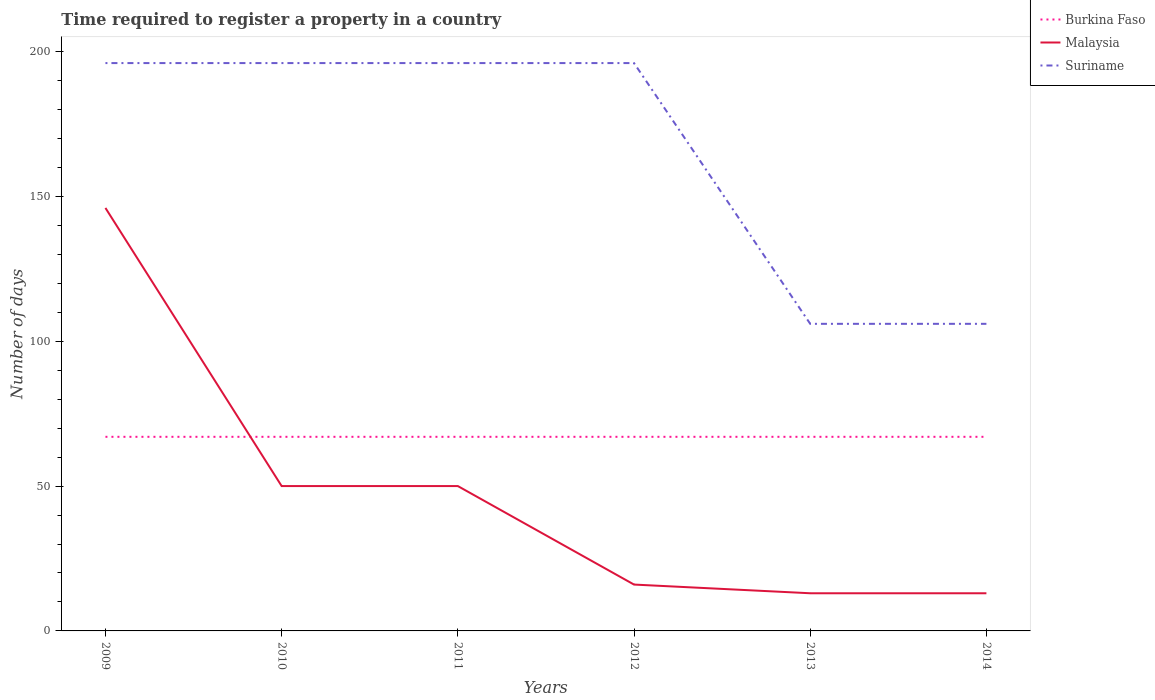How many different coloured lines are there?
Provide a succinct answer. 3. Does the line corresponding to Malaysia intersect with the line corresponding to Burkina Faso?
Your answer should be very brief. Yes. Across all years, what is the maximum number of days required to register a property in Malaysia?
Your answer should be very brief. 13. What is the total number of days required to register a property in Malaysia in the graph?
Offer a very short reply. 96. Is the number of days required to register a property in Malaysia strictly greater than the number of days required to register a property in Burkina Faso over the years?
Provide a short and direct response. No. How many years are there in the graph?
Offer a very short reply. 6. Does the graph contain any zero values?
Make the answer very short. No. Where does the legend appear in the graph?
Make the answer very short. Top right. How many legend labels are there?
Make the answer very short. 3. What is the title of the graph?
Your response must be concise. Time required to register a property in a country. What is the label or title of the Y-axis?
Give a very brief answer. Number of days. What is the Number of days of Burkina Faso in 2009?
Provide a short and direct response. 67. What is the Number of days in Malaysia in 2009?
Make the answer very short. 146. What is the Number of days in Suriname in 2009?
Offer a terse response. 196. What is the Number of days of Malaysia in 2010?
Keep it short and to the point. 50. What is the Number of days in Suriname in 2010?
Your answer should be compact. 196. What is the Number of days in Burkina Faso in 2011?
Your response must be concise. 67. What is the Number of days of Malaysia in 2011?
Keep it short and to the point. 50. What is the Number of days of Suriname in 2011?
Your response must be concise. 196. What is the Number of days of Burkina Faso in 2012?
Offer a terse response. 67. What is the Number of days in Suriname in 2012?
Offer a very short reply. 196. What is the Number of days of Malaysia in 2013?
Ensure brevity in your answer.  13. What is the Number of days in Suriname in 2013?
Provide a succinct answer. 106. What is the Number of days of Malaysia in 2014?
Offer a terse response. 13. What is the Number of days of Suriname in 2014?
Offer a terse response. 106. Across all years, what is the maximum Number of days of Burkina Faso?
Provide a succinct answer. 67. Across all years, what is the maximum Number of days in Malaysia?
Ensure brevity in your answer.  146. Across all years, what is the maximum Number of days in Suriname?
Provide a short and direct response. 196. Across all years, what is the minimum Number of days of Burkina Faso?
Make the answer very short. 67. Across all years, what is the minimum Number of days of Malaysia?
Your response must be concise. 13. Across all years, what is the minimum Number of days of Suriname?
Keep it short and to the point. 106. What is the total Number of days in Burkina Faso in the graph?
Your response must be concise. 402. What is the total Number of days of Malaysia in the graph?
Keep it short and to the point. 288. What is the total Number of days of Suriname in the graph?
Offer a terse response. 996. What is the difference between the Number of days in Malaysia in 2009 and that in 2010?
Your answer should be compact. 96. What is the difference between the Number of days of Burkina Faso in 2009 and that in 2011?
Your answer should be compact. 0. What is the difference between the Number of days in Malaysia in 2009 and that in 2011?
Your answer should be very brief. 96. What is the difference between the Number of days of Burkina Faso in 2009 and that in 2012?
Offer a very short reply. 0. What is the difference between the Number of days in Malaysia in 2009 and that in 2012?
Offer a terse response. 130. What is the difference between the Number of days in Suriname in 2009 and that in 2012?
Your answer should be very brief. 0. What is the difference between the Number of days in Malaysia in 2009 and that in 2013?
Ensure brevity in your answer.  133. What is the difference between the Number of days in Suriname in 2009 and that in 2013?
Offer a very short reply. 90. What is the difference between the Number of days in Malaysia in 2009 and that in 2014?
Give a very brief answer. 133. What is the difference between the Number of days of Malaysia in 2010 and that in 2011?
Your answer should be compact. 0. What is the difference between the Number of days of Suriname in 2010 and that in 2011?
Make the answer very short. 0. What is the difference between the Number of days in Malaysia in 2010 and that in 2012?
Your response must be concise. 34. What is the difference between the Number of days of Suriname in 2010 and that in 2013?
Make the answer very short. 90. What is the difference between the Number of days in Burkina Faso in 2010 and that in 2014?
Offer a terse response. 0. What is the difference between the Number of days in Malaysia in 2010 and that in 2014?
Provide a succinct answer. 37. What is the difference between the Number of days of Malaysia in 2011 and that in 2012?
Give a very brief answer. 34. What is the difference between the Number of days of Burkina Faso in 2011 and that in 2013?
Your answer should be compact. 0. What is the difference between the Number of days of Burkina Faso in 2011 and that in 2014?
Ensure brevity in your answer.  0. What is the difference between the Number of days of Burkina Faso in 2012 and that in 2014?
Provide a short and direct response. 0. What is the difference between the Number of days in Suriname in 2013 and that in 2014?
Your response must be concise. 0. What is the difference between the Number of days of Burkina Faso in 2009 and the Number of days of Suriname in 2010?
Provide a short and direct response. -129. What is the difference between the Number of days of Burkina Faso in 2009 and the Number of days of Suriname in 2011?
Provide a succinct answer. -129. What is the difference between the Number of days in Burkina Faso in 2009 and the Number of days in Suriname in 2012?
Offer a terse response. -129. What is the difference between the Number of days of Burkina Faso in 2009 and the Number of days of Malaysia in 2013?
Ensure brevity in your answer.  54. What is the difference between the Number of days in Burkina Faso in 2009 and the Number of days in Suriname in 2013?
Ensure brevity in your answer.  -39. What is the difference between the Number of days in Burkina Faso in 2009 and the Number of days in Suriname in 2014?
Your answer should be very brief. -39. What is the difference between the Number of days of Malaysia in 2009 and the Number of days of Suriname in 2014?
Ensure brevity in your answer.  40. What is the difference between the Number of days of Burkina Faso in 2010 and the Number of days of Suriname in 2011?
Provide a succinct answer. -129. What is the difference between the Number of days of Malaysia in 2010 and the Number of days of Suriname in 2011?
Your answer should be very brief. -146. What is the difference between the Number of days of Burkina Faso in 2010 and the Number of days of Suriname in 2012?
Give a very brief answer. -129. What is the difference between the Number of days of Malaysia in 2010 and the Number of days of Suriname in 2012?
Provide a succinct answer. -146. What is the difference between the Number of days of Burkina Faso in 2010 and the Number of days of Malaysia in 2013?
Your answer should be very brief. 54. What is the difference between the Number of days in Burkina Faso in 2010 and the Number of days in Suriname in 2013?
Make the answer very short. -39. What is the difference between the Number of days of Malaysia in 2010 and the Number of days of Suriname in 2013?
Offer a terse response. -56. What is the difference between the Number of days of Burkina Faso in 2010 and the Number of days of Suriname in 2014?
Offer a very short reply. -39. What is the difference between the Number of days of Malaysia in 2010 and the Number of days of Suriname in 2014?
Provide a short and direct response. -56. What is the difference between the Number of days of Burkina Faso in 2011 and the Number of days of Suriname in 2012?
Ensure brevity in your answer.  -129. What is the difference between the Number of days in Malaysia in 2011 and the Number of days in Suriname in 2012?
Your answer should be compact. -146. What is the difference between the Number of days of Burkina Faso in 2011 and the Number of days of Malaysia in 2013?
Provide a succinct answer. 54. What is the difference between the Number of days of Burkina Faso in 2011 and the Number of days of Suriname in 2013?
Offer a very short reply. -39. What is the difference between the Number of days in Malaysia in 2011 and the Number of days in Suriname in 2013?
Ensure brevity in your answer.  -56. What is the difference between the Number of days in Burkina Faso in 2011 and the Number of days in Malaysia in 2014?
Keep it short and to the point. 54. What is the difference between the Number of days in Burkina Faso in 2011 and the Number of days in Suriname in 2014?
Your response must be concise. -39. What is the difference between the Number of days in Malaysia in 2011 and the Number of days in Suriname in 2014?
Offer a very short reply. -56. What is the difference between the Number of days of Burkina Faso in 2012 and the Number of days of Malaysia in 2013?
Your response must be concise. 54. What is the difference between the Number of days in Burkina Faso in 2012 and the Number of days in Suriname in 2013?
Your response must be concise. -39. What is the difference between the Number of days in Malaysia in 2012 and the Number of days in Suriname in 2013?
Your answer should be compact. -90. What is the difference between the Number of days of Burkina Faso in 2012 and the Number of days of Suriname in 2014?
Your response must be concise. -39. What is the difference between the Number of days in Malaysia in 2012 and the Number of days in Suriname in 2014?
Keep it short and to the point. -90. What is the difference between the Number of days in Burkina Faso in 2013 and the Number of days in Suriname in 2014?
Offer a terse response. -39. What is the difference between the Number of days of Malaysia in 2013 and the Number of days of Suriname in 2014?
Offer a very short reply. -93. What is the average Number of days of Suriname per year?
Provide a succinct answer. 166. In the year 2009, what is the difference between the Number of days of Burkina Faso and Number of days of Malaysia?
Your answer should be very brief. -79. In the year 2009, what is the difference between the Number of days in Burkina Faso and Number of days in Suriname?
Your answer should be very brief. -129. In the year 2009, what is the difference between the Number of days of Malaysia and Number of days of Suriname?
Make the answer very short. -50. In the year 2010, what is the difference between the Number of days in Burkina Faso and Number of days in Suriname?
Provide a short and direct response. -129. In the year 2010, what is the difference between the Number of days of Malaysia and Number of days of Suriname?
Keep it short and to the point. -146. In the year 2011, what is the difference between the Number of days of Burkina Faso and Number of days of Suriname?
Offer a very short reply. -129. In the year 2011, what is the difference between the Number of days in Malaysia and Number of days in Suriname?
Offer a terse response. -146. In the year 2012, what is the difference between the Number of days in Burkina Faso and Number of days in Malaysia?
Keep it short and to the point. 51. In the year 2012, what is the difference between the Number of days in Burkina Faso and Number of days in Suriname?
Your answer should be very brief. -129. In the year 2012, what is the difference between the Number of days in Malaysia and Number of days in Suriname?
Your answer should be very brief. -180. In the year 2013, what is the difference between the Number of days of Burkina Faso and Number of days of Malaysia?
Give a very brief answer. 54. In the year 2013, what is the difference between the Number of days in Burkina Faso and Number of days in Suriname?
Offer a very short reply. -39. In the year 2013, what is the difference between the Number of days of Malaysia and Number of days of Suriname?
Your answer should be very brief. -93. In the year 2014, what is the difference between the Number of days of Burkina Faso and Number of days of Malaysia?
Make the answer very short. 54. In the year 2014, what is the difference between the Number of days in Burkina Faso and Number of days in Suriname?
Offer a very short reply. -39. In the year 2014, what is the difference between the Number of days of Malaysia and Number of days of Suriname?
Keep it short and to the point. -93. What is the ratio of the Number of days of Burkina Faso in 2009 to that in 2010?
Your response must be concise. 1. What is the ratio of the Number of days in Malaysia in 2009 to that in 2010?
Provide a short and direct response. 2.92. What is the ratio of the Number of days in Suriname in 2009 to that in 2010?
Give a very brief answer. 1. What is the ratio of the Number of days in Burkina Faso in 2009 to that in 2011?
Provide a succinct answer. 1. What is the ratio of the Number of days of Malaysia in 2009 to that in 2011?
Offer a terse response. 2.92. What is the ratio of the Number of days in Suriname in 2009 to that in 2011?
Offer a terse response. 1. What is the ratio of the Number of days in Malaysia in 2009 to that in 2012?
Keep it short and to the point. 9.12. What is the ratio of the Number of days of Malaysia in 2009 to that in 2013?
Offer a terse response. 11.23. What is the ratio of the Number of days in Suriname in 2009 to that in 2013?
Ensure brevity in your answer.  1.85. What is the ratio of the Number of days of Malaysia in 2009 to that in 2014?
Ensure brevity in your answer.  11.23. What is the ratio of the Number of days in Suriname in 2009 to that in 2014?
Make the answer very short. 1.85. What is the ratio of the Number of days in Malaysia in 2010 to that in 2011?
Your answer should be compact. 1. What is the ratio of the Number of days of Malaysia in 2010 to that in 2012?
Offer a very short reply. 3.12. What is the ratio of the Number of days of Malaysia in 2010 to that in 2013?
Your answer should be compact. 3.85. What is the ratio of the Number of days of Suriname in 2010 to that in 2013?
Your answer should be very brief. 1.85. What is the ratio of the Number of days in Burkina Faso in 2010 to that in 2014?
Offer a very short reply. 1. What is the ratio of the Number of days in Malaysia in 2010 to that in 2014?
Make the answer very short. 3.85. What is the ratio of the Number of days in Suriname in 2010 to that in 2014?
Keep it short and to the point. 1.85. What is the ratio of the Number of days in Malaysia in 2011 to that in 2012?
Provide a succinct answer. 3.12. What is the ratio of the Number of days in Malaysia in 2011 to that in 2013?
Make the answer very short. 3.85. What is the ratio of the Number of days in Suriname in 2011 to that in 2013?
Offer a terse response. 1.85. What is the ratio of the Number of days in Malaysia in 2011 to that in 2014?
Make the answer very short. 3.85. What is the ratio of the Number of days in Suriname in 2011 to that in 2014?
Your response must be concise. 1.85. What is the ratio of the Number of days in Malaysia in 2012 to that in 2013?
Provide a short and direct response. 1.23. What is the ratio of the Number of days in Suriname in 2012 to that in 2013?
Ensure brevity in your answer.  1.85. What is the ratio of the Number of days of Burkina Faso in 2012 to that in 2014?
Your answer should be very brief. 1. What is the ratio of the Number of days in Malaysia in 2012 to that in 2014?
Your answer should be very brief. 1.23. What is the ratio of the Number of days in Suriname in 2012 to that in 2014?
Provide a short and direct response. 1.85. What is the ratio of the Number of days in Suriname in 2013 to that in 2014?
Offer a very short reply. 1. What is the difference between the highest and the second highest Number of days of Burkina Faso?
Keep it short and to the point. 0. What is the difference between the highest and the second highest Number of days of Malaysia?
Provide a succinct answer. 96. What is the difference between the highest and the lowest Number of days in Malaysia?
Make the answer very short. 133. What is the difference between the highest and the lowest Number of days in Suriname?
Give a very brief answer. 90. 